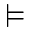Convert formula to latex. <formula><loc_0><loc_0><loc_500><loc_500>\vDash</formula> 